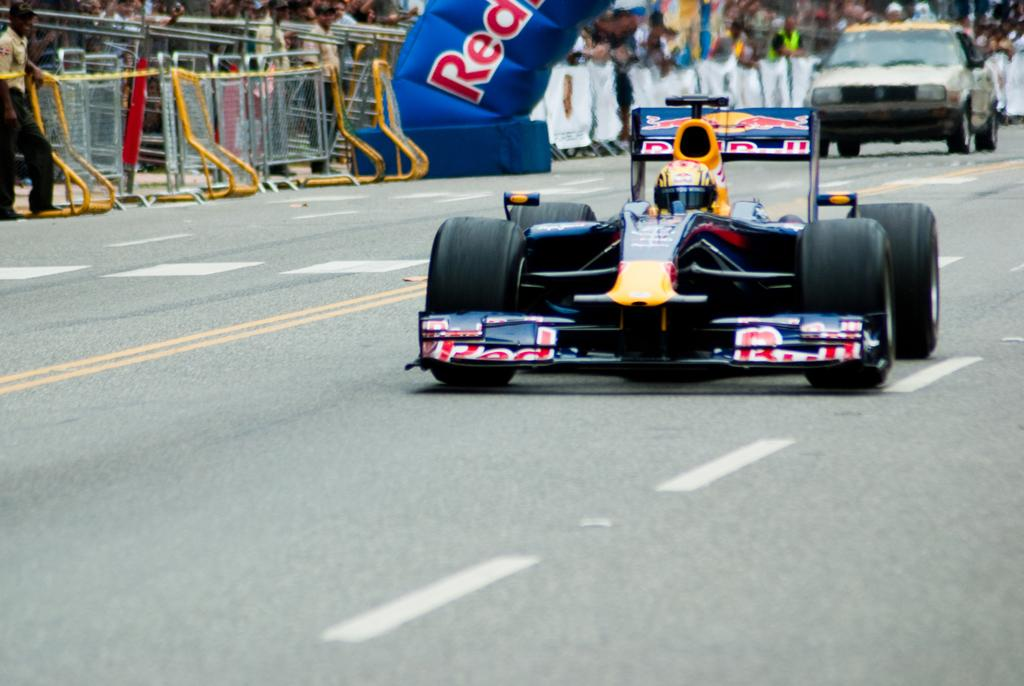What can be seen on the road in the image? There are vehicles on the road in the image. What type of barrier is visible in the image? There is fencing visible in the image. What are the people in the image doing? There are people standing and watching in the image. What type of ring can be seen on the finger of the person standing in the image? There is no ring visible on any person's finger in the image. What type of bag is being carried by the person standing in the image? There is no bag visible in the image. What type of rice is being cooked in the image? There is no rice or cooking activity present in the image. 